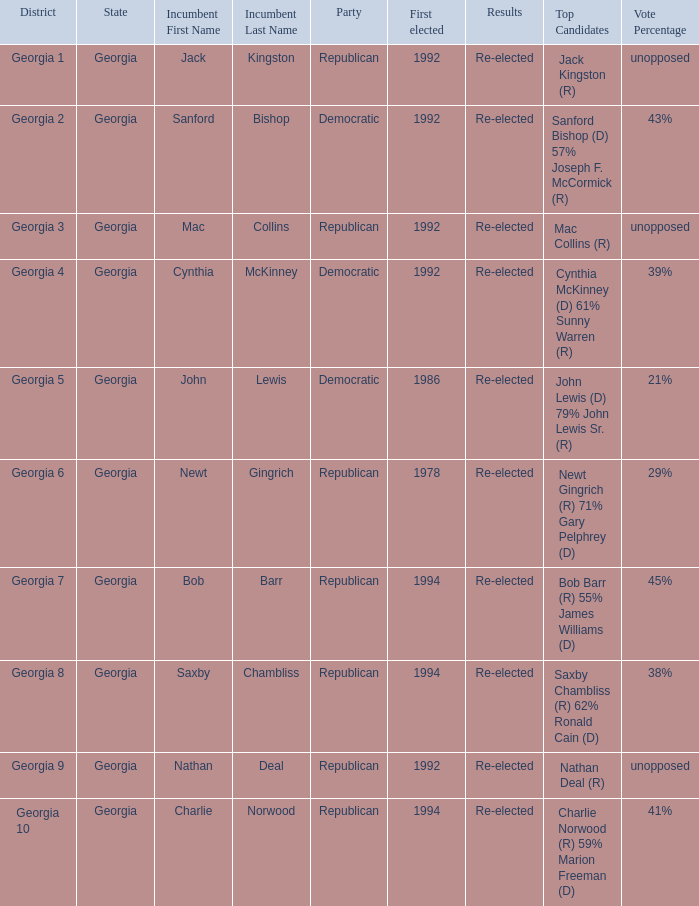In the election where saxby chambliss served as the incumbent, who were the other contenders? Saxby Chambliss (R) 62% Ronald Cain (D) 38%. 